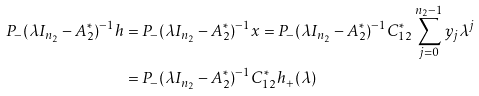<formula> <loc_0><loc_0><loc_500><loc_500>P _ { - } ( \lambda I _ { n _ { 2 } } - A _ { 2 } ^ { * } ) ^ { - 1 } h & = P _ { - } ( \lambda I _ { n _ { 2 } } - A _ { 2 } ^ { * } ) ^ { - 1 } x = P _ { - } ( \lambda I _ { n _ { 2 } } - A _ { 2 } ^ { * } ) ^ { - 1 } C _ { 1 2 } ^ { * } \sum _ { j = 0 } ^ { n _ { 2 } - 1 } y _ { j } \lambda ^ { j } \\ & = P _ { - } ( \lambda I _ { n _ { 2 } } - A _ { 2 } ^ { * } ) ^ { - 1 } C _ { 1 2 } ^ { * } h _ { + } ( \lambda )</formula> 